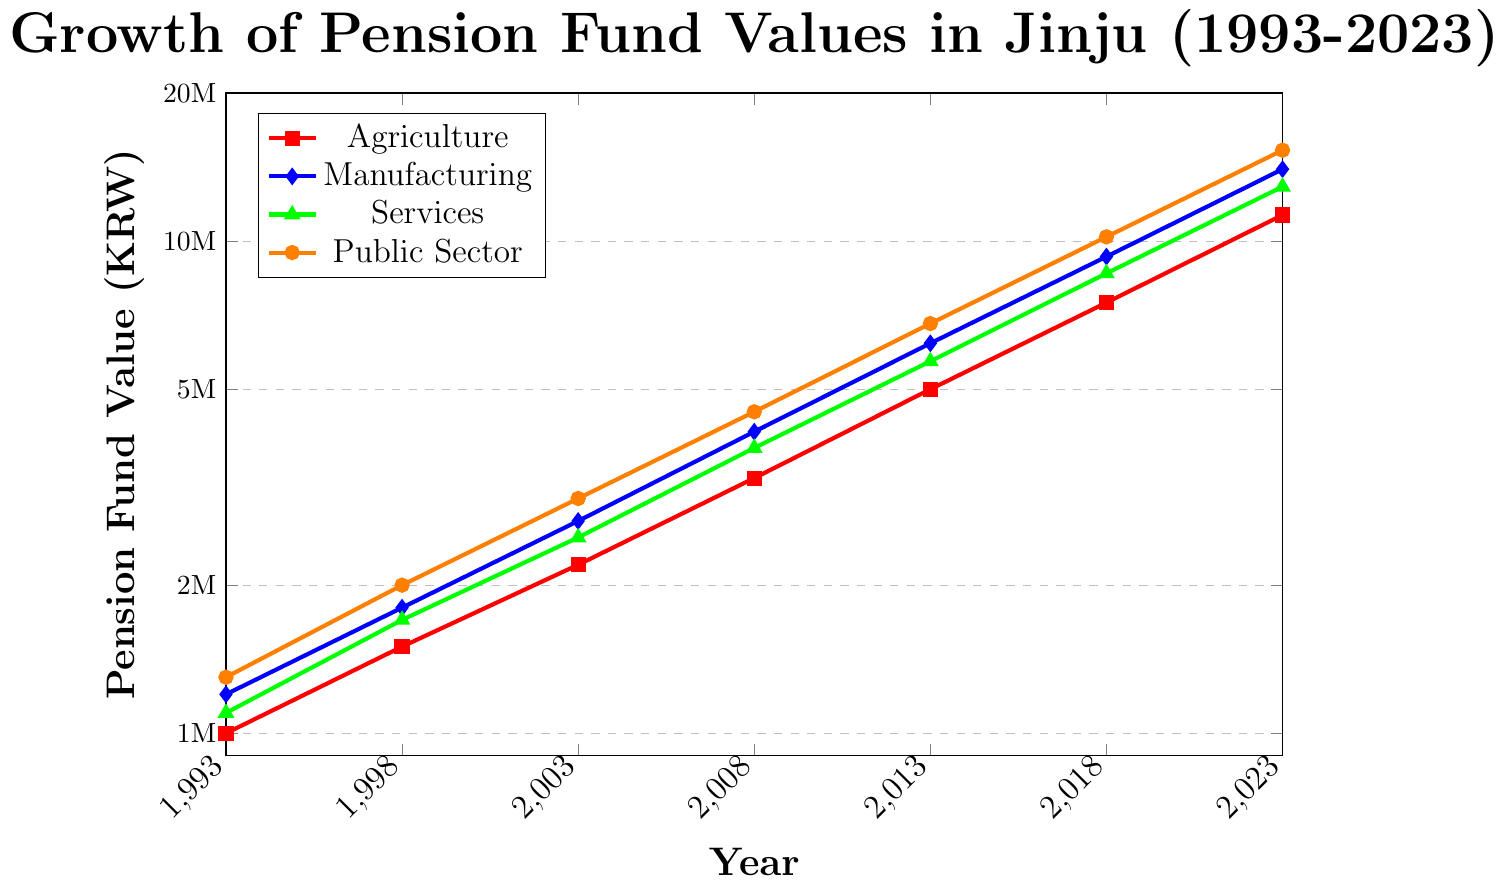Which occupation sector had the highest pension fund value in 2023? Check the values corresponding to 2023 from all sectors. The Public Sector has a pension fund value of 15300000 KRW.
Answer: Public Sector What was the pension fund value for the Agriculture sector in 1993? Refer to the value of the Agriculture sector in 1993 on the chart, which is 1000000 KRW.
Answer: 1000000 KRW How much did the pension fund value for Manufacturing increase from 1998 to 2008? Subtract the 1998 value from the 2008 value: 4100000 - 1800000 = 2300000 KRW.
Answer: 2300000 KRW Which sector experienced the smallest increase in pension fund value from 2013 to 2018? Calculate the increase for each sector and compare:
- Agriculture: 7500000 - 5000000 = 2500000
- Manufacturing: 9300000 - 6200000 = 3100000
- Services: 8600000 - 5700000 = 2900000
- Public Sector: 10200000 - 6800000 = 3400000
Agriculture had the smallest increase of 2500000 KRW.
Answer: Agriculture What is the difference in pension fund value between the Public Sector and Services in 2023? Subtract the Services value from the Public Sector value: 15300000 - 12900000 = 2400000 KRW.
Answer: 2400000 KRW What was the average pension fund value for all sectors in 2018? Sum all the 2018 values and divide by 4:
(7500000 + 9300000 + 8600000 + 10200000) / 4 = 9025000 KRW.
Answer: 9025000 KRW Between which consecutive five-year periods did the Manufacturing sector see the greatest increase in pension fund value? Calculate increases for each period and compare:
- 1993-1998: 1800000 - 1200000 = 600000
- 1998-2003: 2700000 - 1800000 = 900000
- 2003-2008: 4100000 - 2700000 = 1400000
- 2008-2013: 6200000 - 4100000 = 2100000
- 2013-2018: 9300000 - 6200000 = 3100000
- 2018-2023: 14000000 - 9300000 = 4700000
The greatest increase is from 2018 to 2023 with 4700000 KRW.
Answer: 2018-2023 